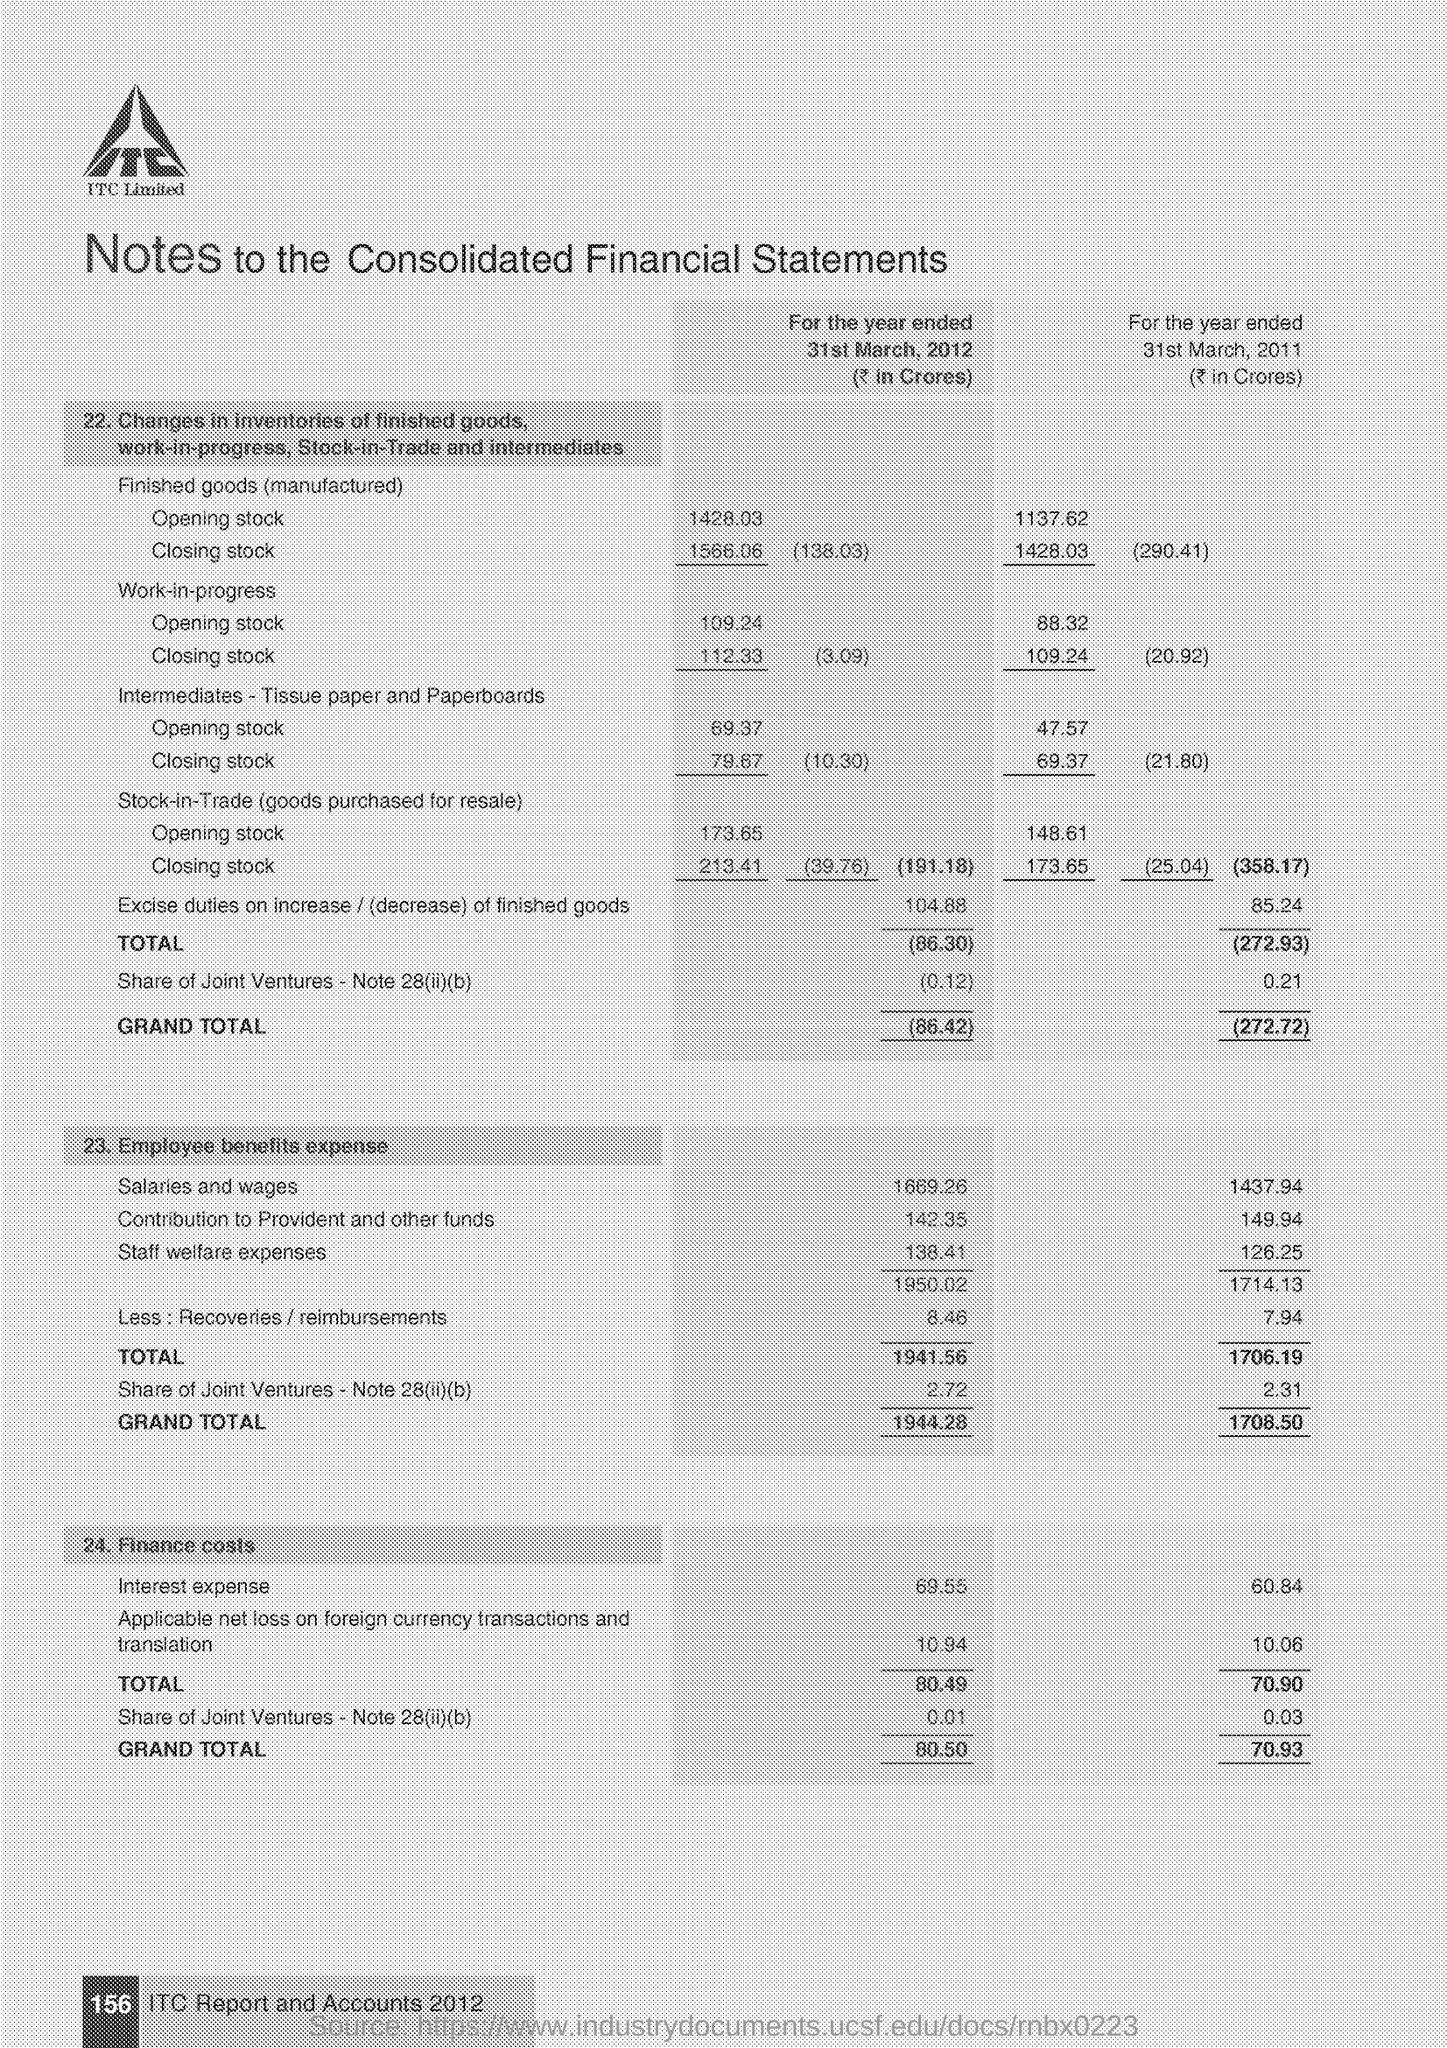Indicate a few pertinent items in this graphic. The grand total of finance costs for the year ended March 31, 2011 was 70.93 crores. The opening stock for the finished goods (manufactured) for the year ended March 31, 2011 was 1137.62 crores. The opening stock for the finished goods (manufactured) for the year ended March 31, 2012 was 1428.03 crores. The grand total of employee benefits expense for the year ended March 31, 2011, was 1708.50 crores. The grand total of employee benefits expense for the year ended March 31, 2012 is 1944.28 crores. 